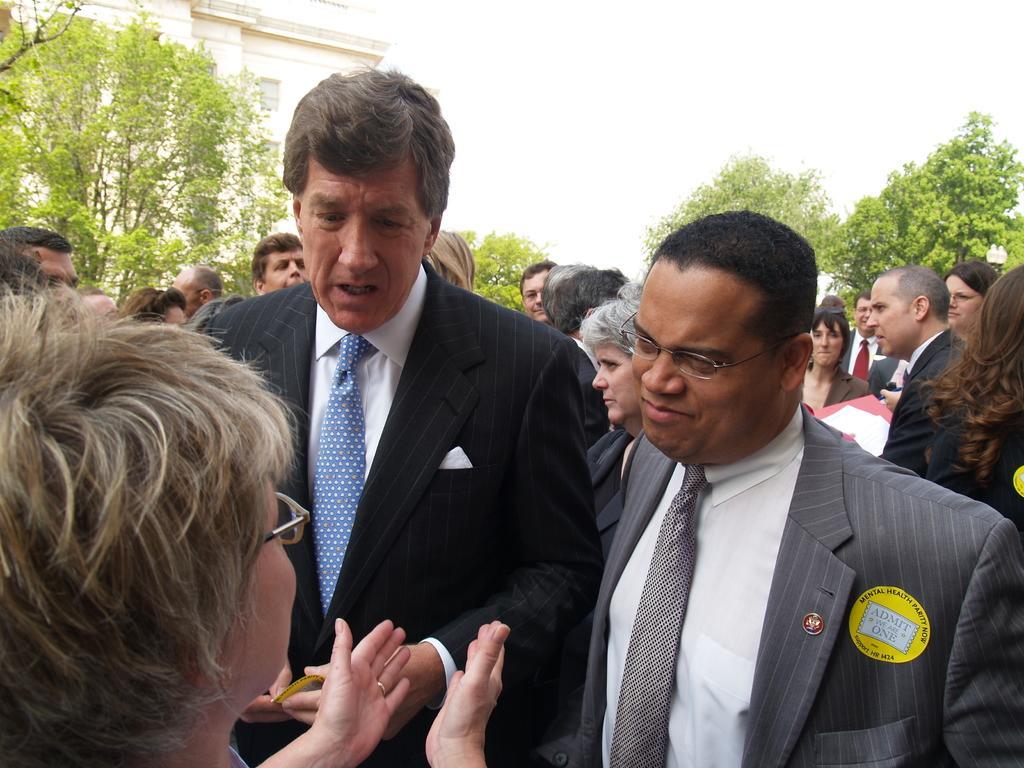In one or two sentences, can you explain what this image depicts? In this picture we can see some people are standing, there are some trees in the middle, we can see a building on the left side, there is the sky at the top of the picture. 